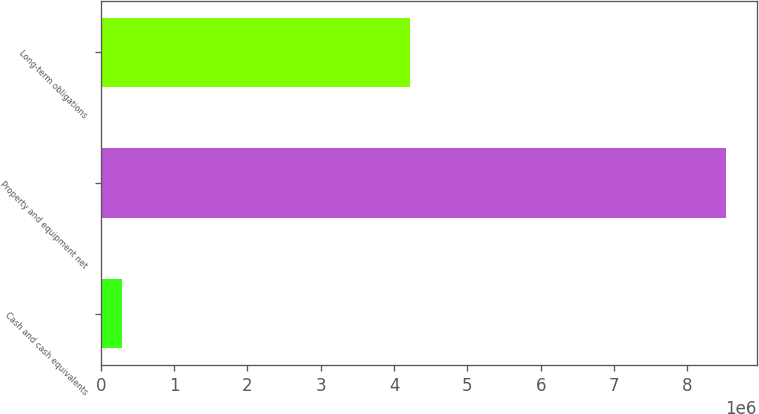<chart> <loc_0><loc_0><loc_500><loc_500><bar_chart><fcel>Cash and cash equivalents<fcel>Property and equipment net<fcel>Long-term obligations<nl><fcel>295129<fcel>8.51993e+06<fcel>4.21158e+06<nl></chart> 